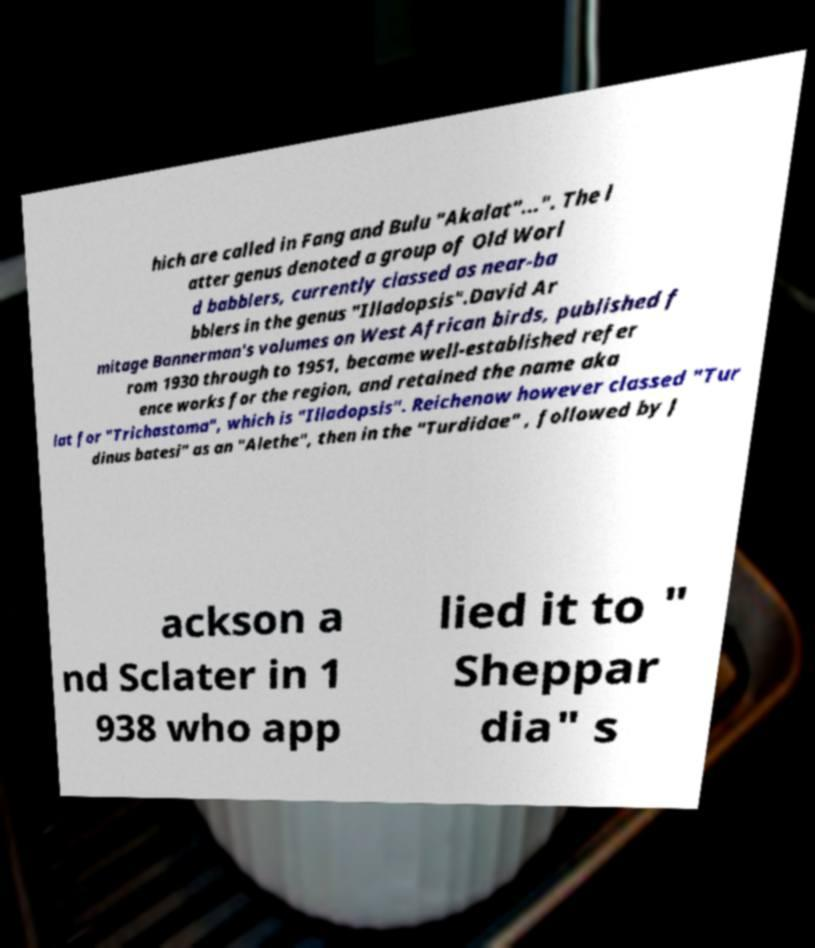Could you extract and type out the text from this image? hich are called in Fang and Bulu "Akalat"...". The l atter genus denoted a group of Old Worl d babblers, currently classed as near-ba bblers in the genus "Illadopsis".David Ar mitage Bannerman's volumes on West African birds, published f rom 1930 through to 1951, became well-established refer ence works for the region, and retained the name aka lat for "Trichastoma", which is "Illadopsis". Reichenow however classed "Tur dinus batesi" as an "Alethe", then in the "Turdidae" , followed by J ackson a nd Sclater in 1 938 who app lied it to " Sheppar dia" s 